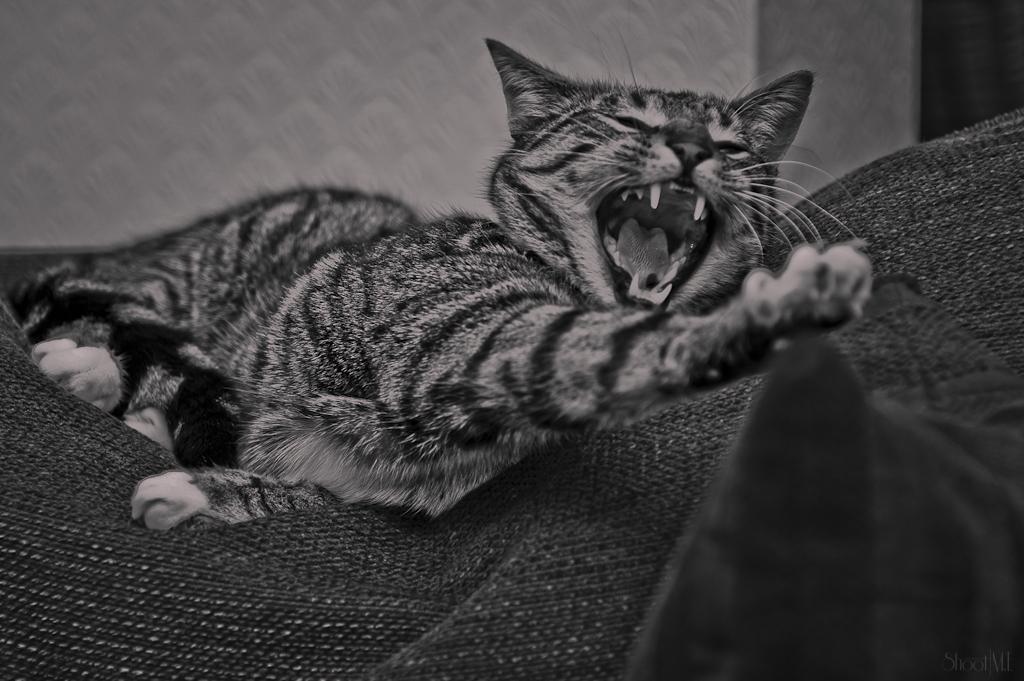In one or two sentences, can you explain what this image depicts? This is a black and white image. In the center of the image there is a cat. At the bottom there is a cloth. At the top it is wall painted white. 